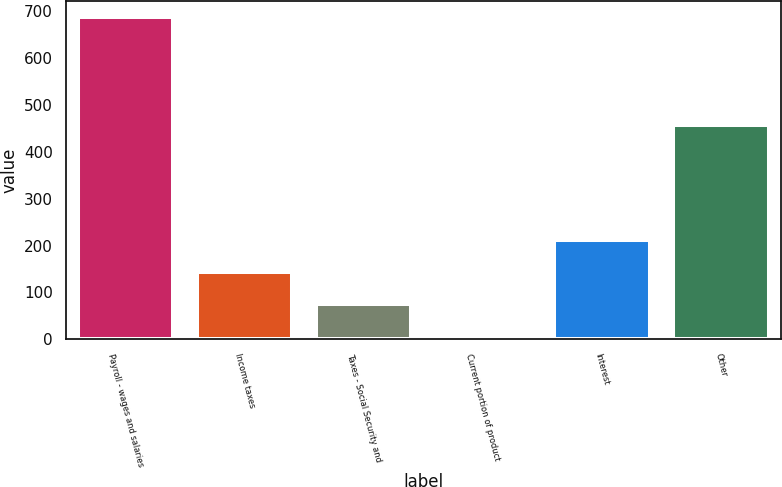Convert chart to OTSL. <chart><loc_0><loc_0><loc_500><loc_500><bar_chart><fcel>Payroll - wages and salaries<fcel>Income taxes<fcel>Taxes - Social Security and<fcel>Current portion of product<fcel>Interest<fcel>Other<nl><fcel>688<fcel>143.2<fcel>75.1<fcel>7<fcel>211.3<fcel>458<nl></chart> 